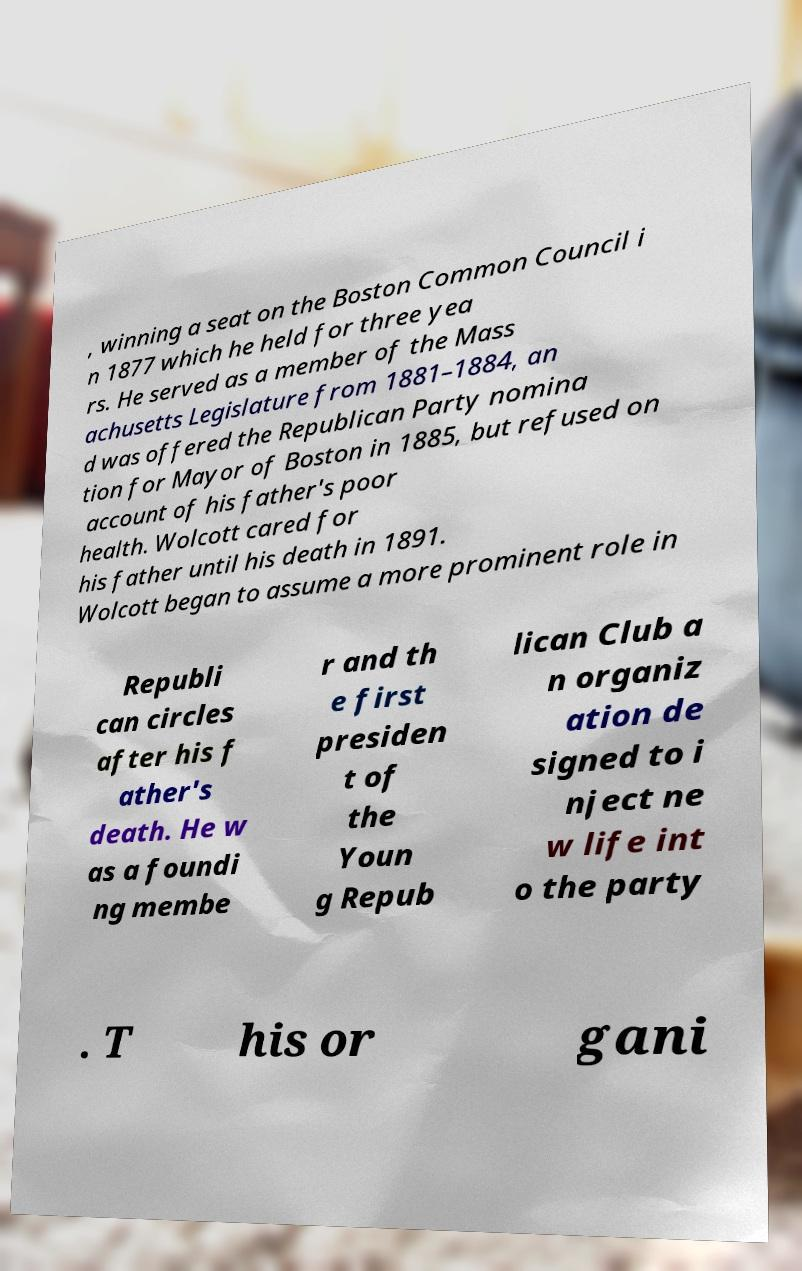Please read and relay the text visible in this image. What does it say? , winning a seat on the Boston Common Council i n 1877 which he held for three yea rs. He served as a member of the Mass achusetts Legislature from 1881–1884, an d was offered the Republican Party nomina tion for Mayor of Boston in 1885, but refused on account of his father's poor health. Wolcott cared for his father until his death in 1891. Wolcott began to assume a more prominent role in Republi can circles after his f ather's death. He w as a foundi ng membe r and th e first presiden t of the Youn g Repub lican Club a n organiz ation de signed to i nject ne w life int o the party . T his or gani 